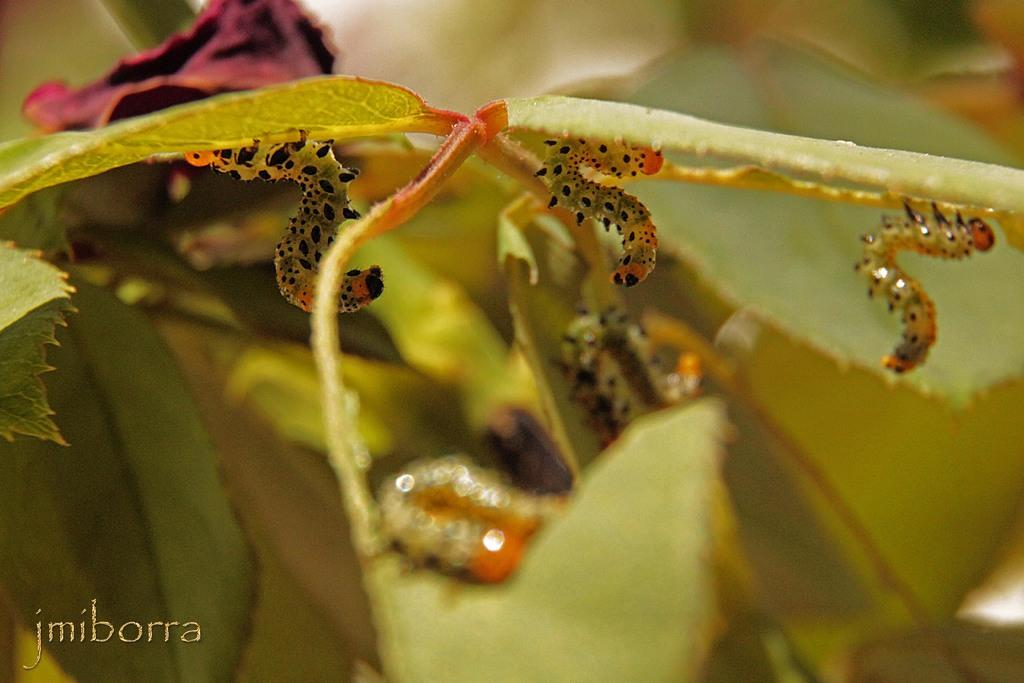What type of animals are in the image? There are caterpillars in the image. Where are the caterpillars located? The caterpillars are on a plant. What can be found on the plant besides the caterpillars? The plant has leaves. What type of drink is being served in the image? There is no drink present in the image; it features caterpillars on a plant with leaves. 